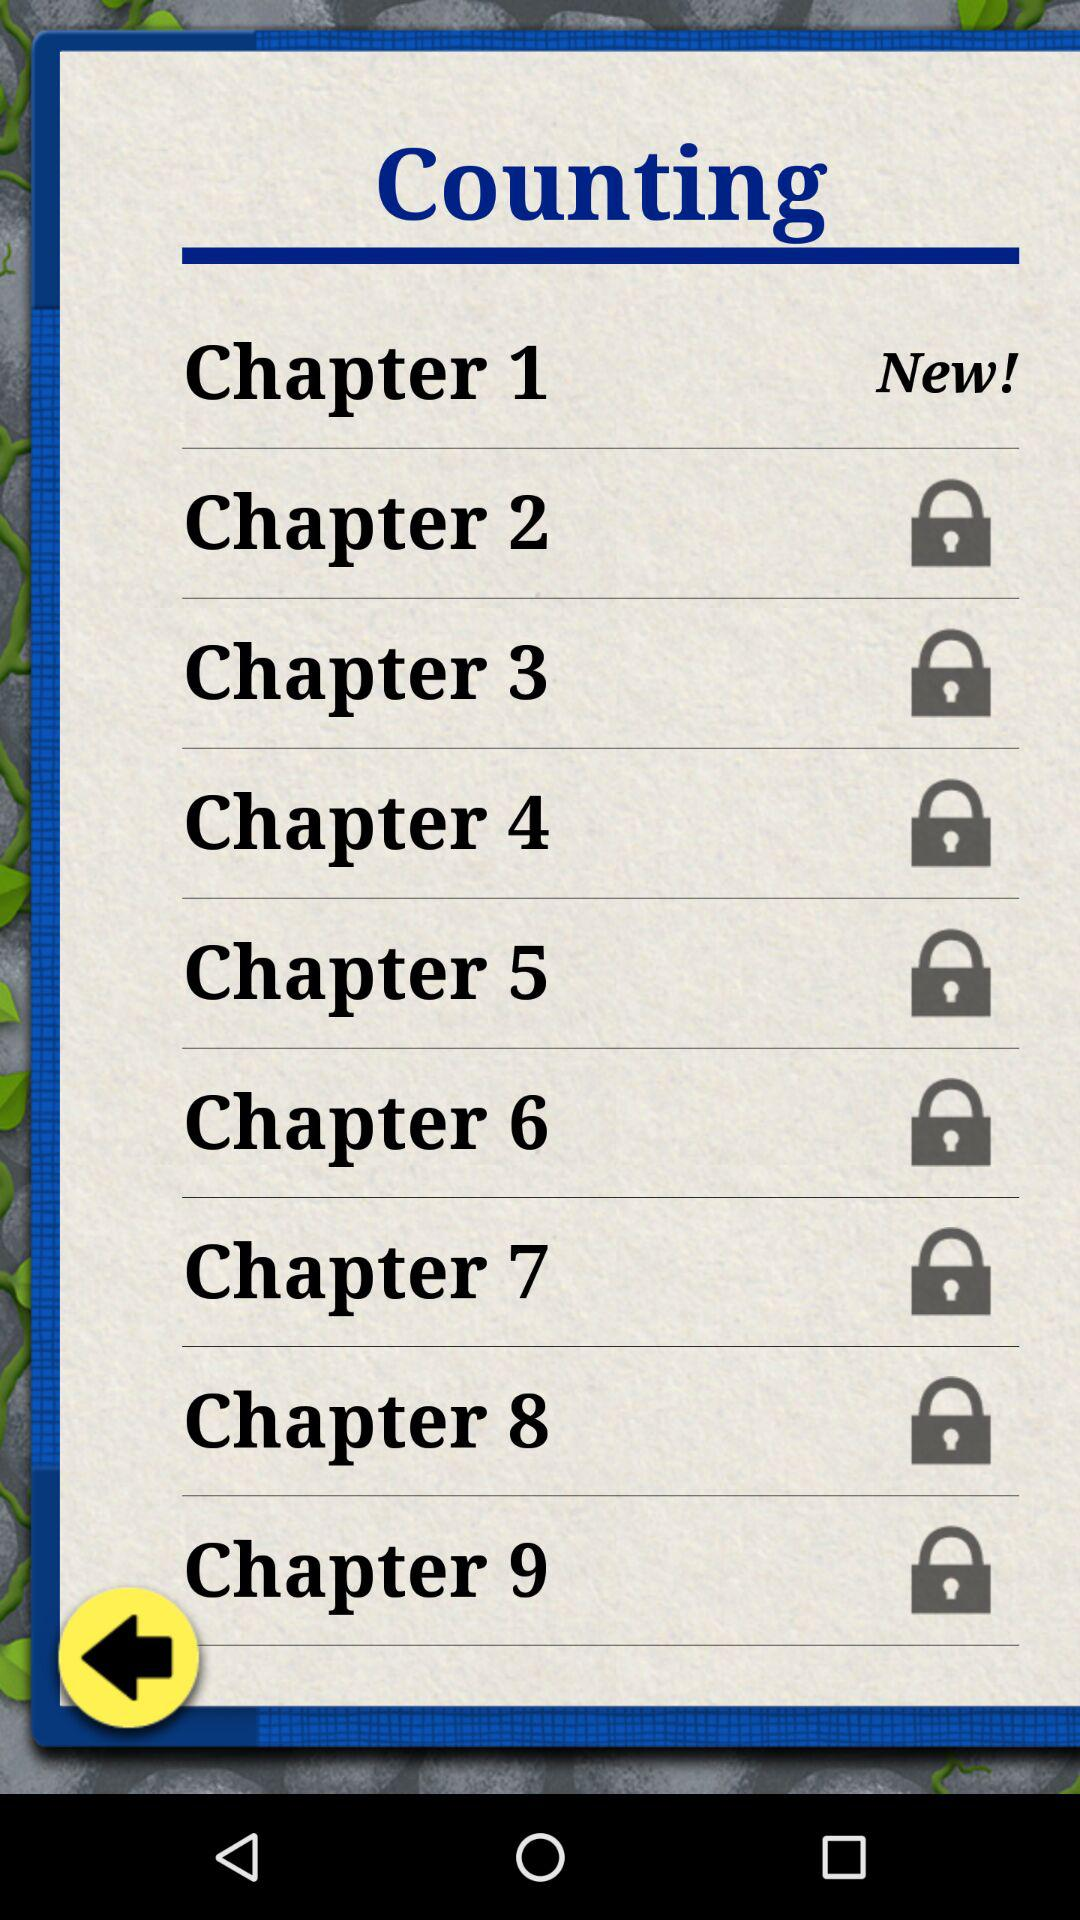What is the status of chapter one?
When the provided information is insufficient, respond with <no answer>. <no answer> 